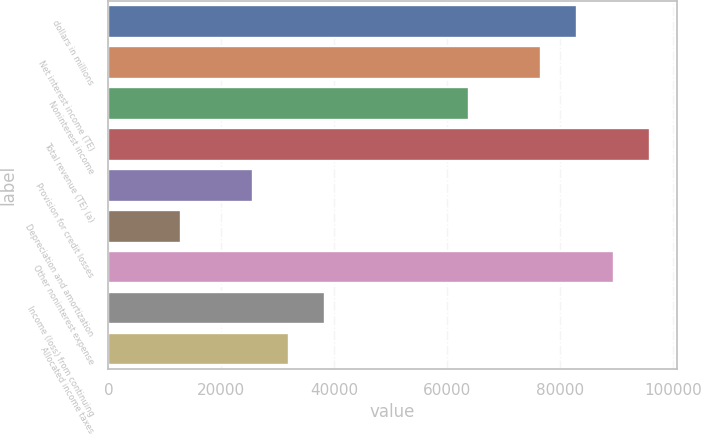Convert chart to OTSL. <chart><loc_0><loc_0><loc_500><loc_500><bar_chart><fcel>dollars in millions<fcel>Net interest income (TE)<fcel>Noninterest income<fcel>Total revenue (TE) (a)<fcel>Provision for credit losses<fcel>Depreciation and amortization<fcel>Other noninterest expense<fcel>Income (loss) from continuing<fcel>Allocated income taxes<nl><fcel>83034.2<fcel>76647.8<fcel>63875<fcel>95807<fcel>25556.6<fcel>12783.8<fcel>89420.6<fcel>38329.4<fcel>31943<nl></chart> 